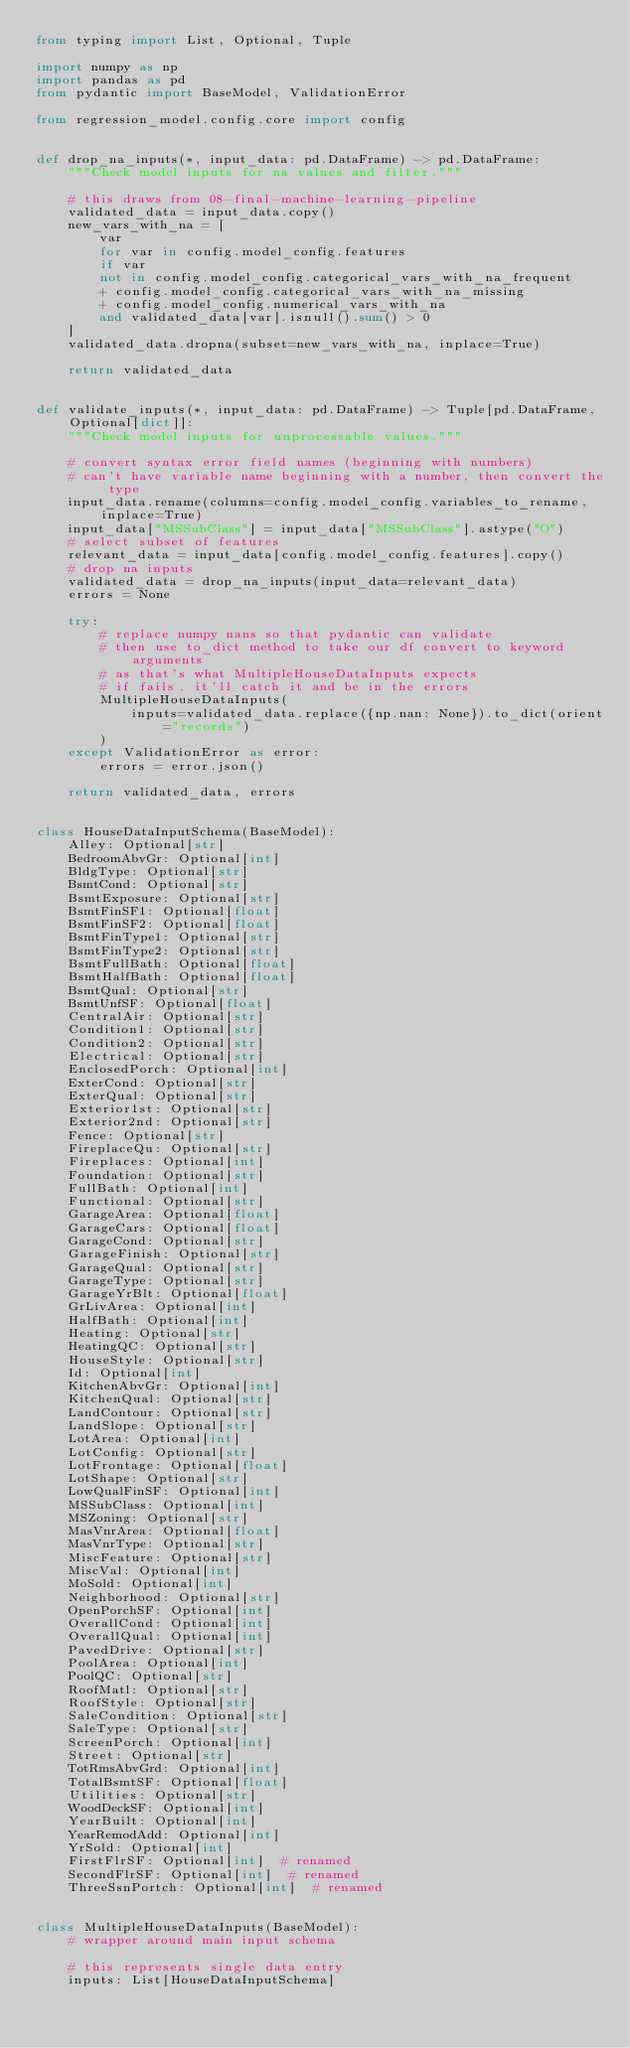<code> <loc_0><loc_0><loc_500><loc_500><_Python_>from typing import List, Optional, Tuple

import numpy as np
import pandas as pd
from pydantic import BaseModel, ValidationError

from regression_model.config.core import config


def drop_na_inputs(*, input_data: pd.DataFrame) -> pd.DataFrame:
    """Check model inputs for na values and filter."""

    # this draws from 08-final-machine-learning-pipeline
    validated_data = input_data.copy()
    new_vars_with_na = [
        var
        for var in config.model_config.features
        if var
        not in config.model_config.categorical_vars_with_na_frequent
        + config.model_config.categorical_vars_with_na_missing
        + config.model_config.numerical_vars_with_na
        and validated_data[var].isnull().sum() > 0
    ]
    validated_data.dropna(subset=new_vars_with_na, inplace=True)

    return validated_data


def validate_inputs(*, input_data: pd.DataFrame) -> Tuple[pd.DataFrame, Optional[dict]]:
    """Check model inputs for unprocessable values."""

    # convert syntax error field names (beginning with numbers)
    # can't have variable name beginning with a number, then convert the type
    input_data.rename(columns=config.model_config.variables_to_rename, inplace=True)
    input_data["MSSubClass"] = input_data["MSSubClass"].astype("O")
    # select subset of features
    relevant_data = input_data[config.model_config.features].copy()
    # drop na inputs
    validated_data = drop_na_inputs(input_data=relevant_data)
    errors = None

    try:
        # replace numpy nans so that pydantic can validate
        # then use to_dict method to take our df convert to keyword arguments
        # as that's what MultipleHouseDataInputs expects
        # if fails, it'll catch it and be in the errors
        MultipleHouseDataInputs(
            inputs=validated_data.replace({np.nan: None}).to_dict(orient="records")
        )
    except ValidationError as error:
        errors = error.json()

    return validated_data, errors


class HouseDataInputSchema(BaseModel):
    Alley: Optional[str]
    BedroomAbvGr: Optional[int]
    BldgType: Optional[str]
    BsmtCond: Optional[str]
    BsmtExposure: Optional[str]
    BsmtFinSF1: Optional[float]
    BsmtFinSF2: Optional[float]
    BsmtFinType1: Optional[str]
    BsmtFinType2: Optional[str]
    BsmtFullBath: Optional[float]
    BsmtHalfBath: Optional[float]
    BsmtQual: Optional[str]
    BsmtUnfSF: Optional[float]
    CentralAir: Optional[str]
    Condition1: Optional[str]
    Condition2: Optional[str]
    Electrical: Optional[str]
    EnclosedPorch: Optional[int]
    ExterCond: Optional[str]
    ExterQual: Optional[str]
    Exterior1st: Optional[str]
    Exterior2nd: Optional[str]
    Fence: Optional[str]
    FireplaceQu: Optional[str]
    Fireplaces: Optional[int]
    Foundation: Optional[str]
    FullBath: Optional[int]
    Functional: Optional[str]
    GarageArea: Optional[float]
    GarageCars: Optional[float]
    GarageCond: Optional[str]
    GarageFinish: Optional[str]
    GarageQual: Optional[str]
    GarageType: Optional[str]
    GarageYrBlt: Optional[float]
    GrLivArea: Optional[int]
    HalfBath: Optional[int]
    Heating: Optional[str]
    HeatingQC: Optional[str]
    HouseStyle: Optional[str]
    Id: Optional[int]
    KitchenAbvGr: Optional[int]
    KitchenQual: Optional[str]
    LandContour: Optional[str]
    LandSlope: Optional[str]
    LotArea: Optional[int]
    LotConfig: Optional[str]
    LotFrontage: Optional[float]
    LotShape: Optional[str]
    LowQualFinSF: Optional[int]
    MSSubClass: Optional[int]
    MSZoning: Optional[str]
    MasVnrArea: Optional[float]
    MasVnrType: Optional[str]
    MiscFeature: Optional[str]
    MiscVal: Optional[int]
    MoSold: Optional[int]
    Neighborhood: Optional[str]
    OpenPorchSF: Optional[int]
    OverallCond: Optional[int]
    OverallQual: Optional[int]
    PavedDrive: Optional[str]
    PoolArea: Optional[int]
    PoolQC: Optional[str]
    RoofMatl: Optional[str]
    RoofStyle: Optional[str]
    SaleCondition: Optional[str]
    SaleType: Optional[str]
    ScreenPorch: Optional[int]
    Street: Optional[str]
    TotRmsAbvGrd: Optional[int]
    TotalBsmtSF: Optional[float]
    Utilities: Optional[str]
    WoodDeckSF: Optional[int]
    YearBuilt: Optional[int]
    YearRemodAdd: Optional[int]
    YrSold: Optional[int]
    FirstFlrSF: Optional[int]  # renamed
    SecondFlrSF: Optional[int]  # renamed
    ThreeSsnPortch: Optional[int]  # renamed


class MultipleHouseDataInputs(BaseModel):
    # wrapper around main input schema

    # this represents single data entry
    inputs: List[HouseDataInputSchema]
</code> 